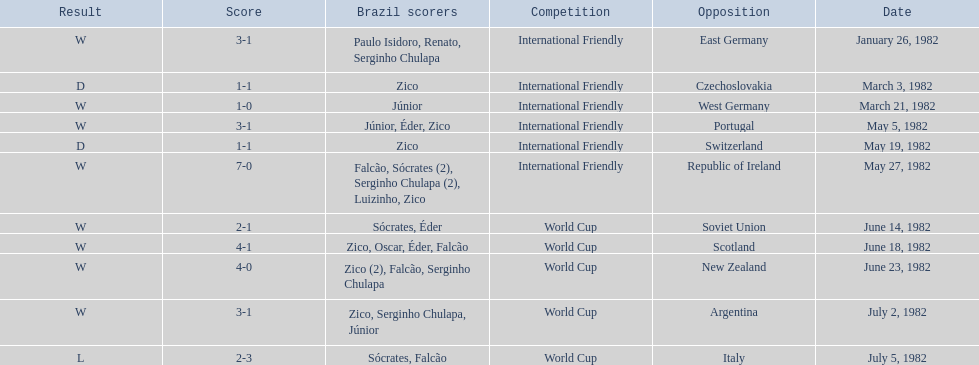What are the dates January 26, 1982, March 3, 1982, March 21, 1982, May 5, 1982, May 19, 1982, May 27, 1982, June 14, 1982, June 18, 1982, June 23, 1982, July 2, 1982, July 5, 1982. Which date is at the top? January 26, 1982. 